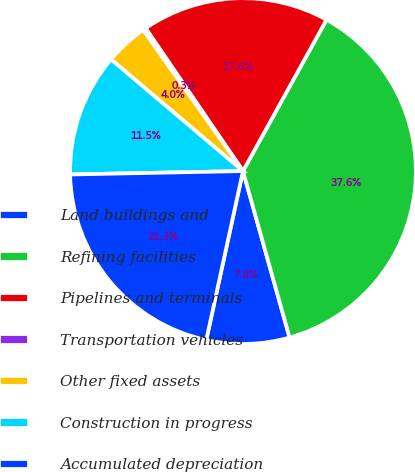Convert chart. <chart><loc_0><loc_0><loc_500><loc_500><pie_chart><fcel>Land buildings and<fcel>Refining facilities<fcel>Pipelines and terminals<fcel>Transportation vehicles<fcel>Other fixed assets<fcel>Construction in progress<fcel>Accumulated depreciation<nl><fcel>7.75%<fcel>37.63%<fcel>17.55%<fcel>0.28%<fcel>4.02%<fcel>11.49%<fcel>21.28%<nl></chart> 